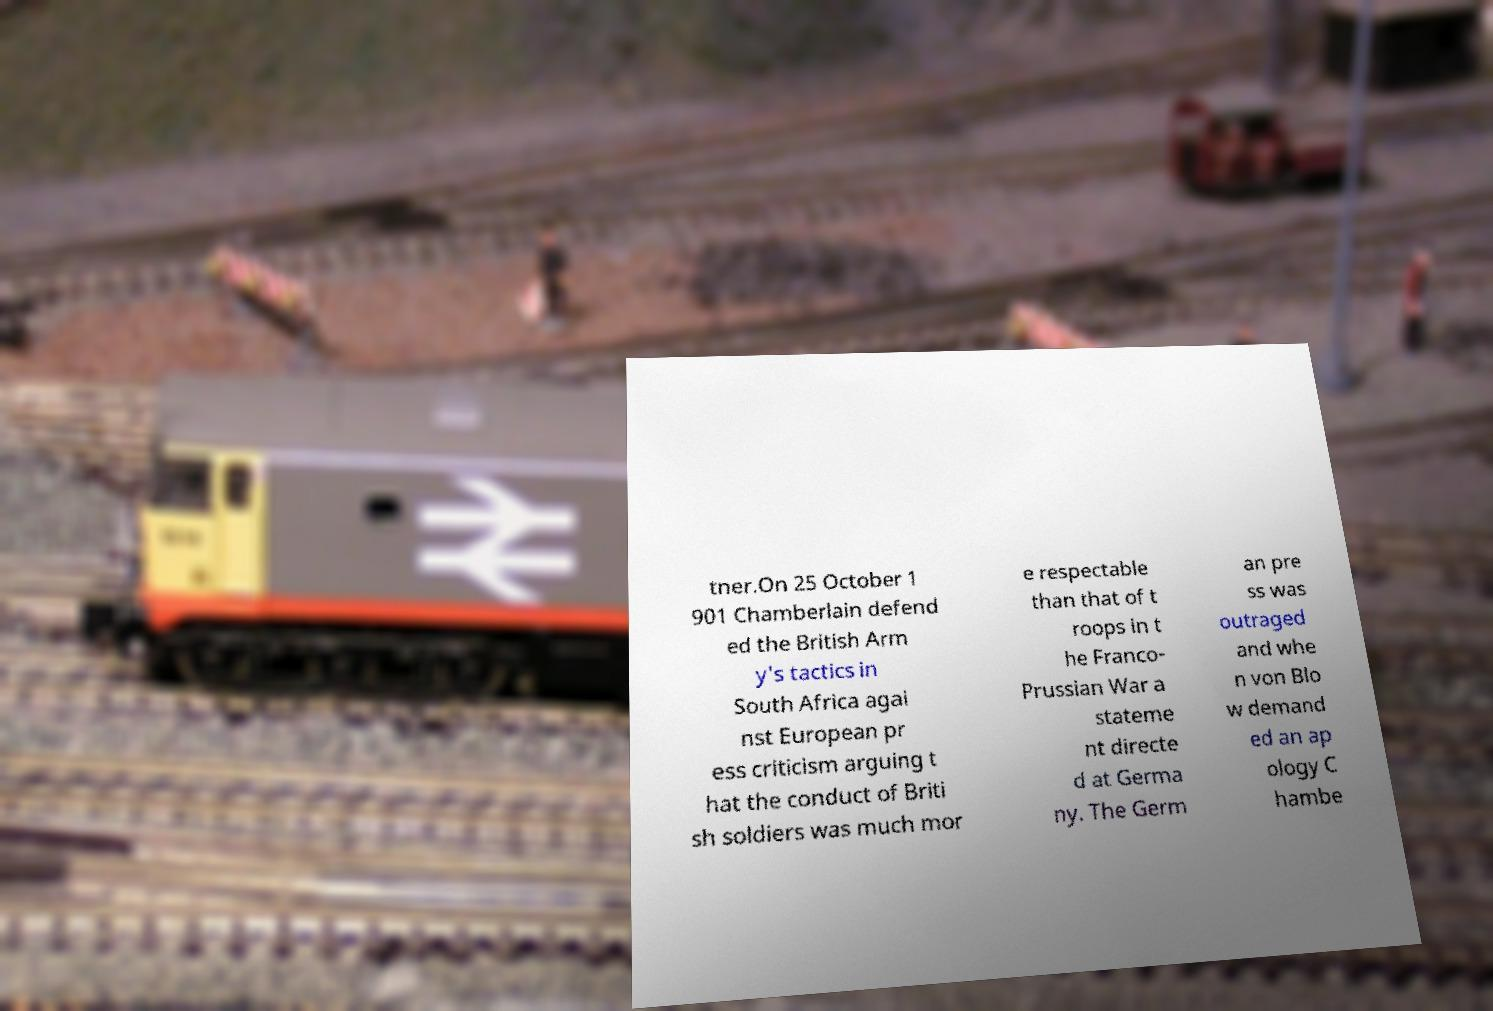Please read and relay the text visible in this image. What does it say? tner.On 25 October 1 901 Chamberlain defend ed the British Arm y's tactics in South Africa agai nst European pr ess criticism arguing t hat the conduct of Briti sh soldiers was much mor e respectable than that of t roops in t he Franco- Prussian War a stateme nt directe d at Germa ny. The Germ an pre ss was outraged and whe n von Blo w demand ed an ap ology C hambe 